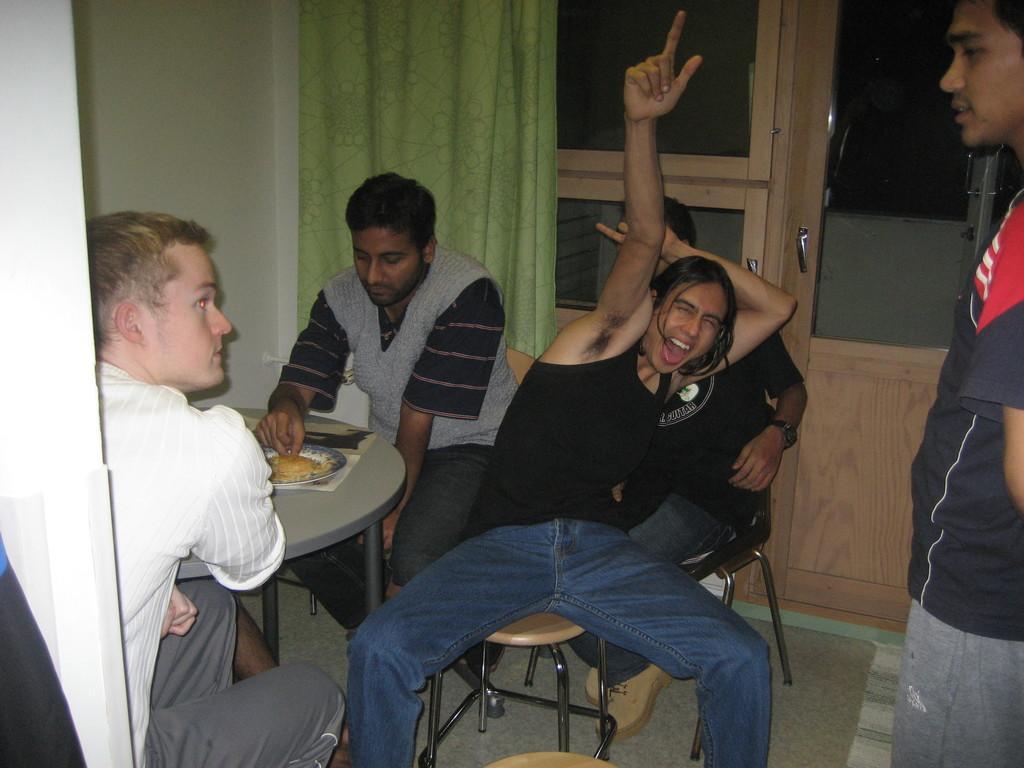Describe this image in one or two sentences. In this image I can see few people were on the right side I can see one man is standing and on the left side I can see rest all are sitting on chairs. I can also see a table on the left side and on it I can see food on a plate. In the background I can see a door and a green colour curtain. 